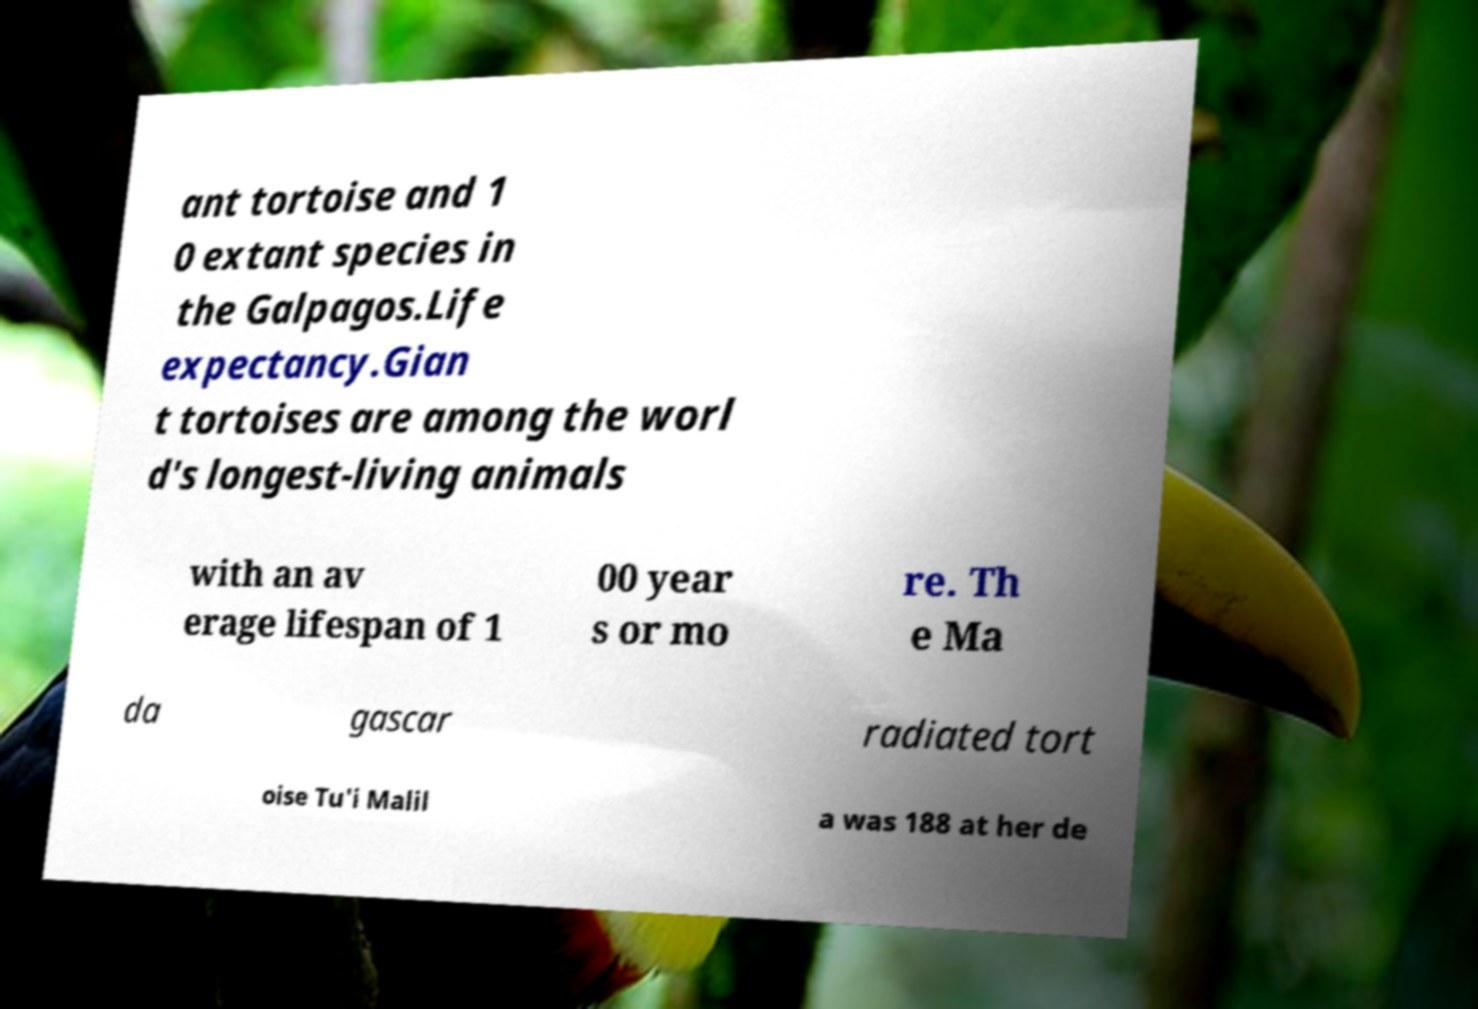Please identify and transcribe the text found in this image. ant tortoise and 1 0 extant species in the Galpagos.Life expectancy.Gian t tortoises are among the worl d's longest-living animals with an av erage lifespan of 1 00 year s or mo re. Th e Ma da gascar radiated tort oise Tu'i Malil a was 188 at her de 